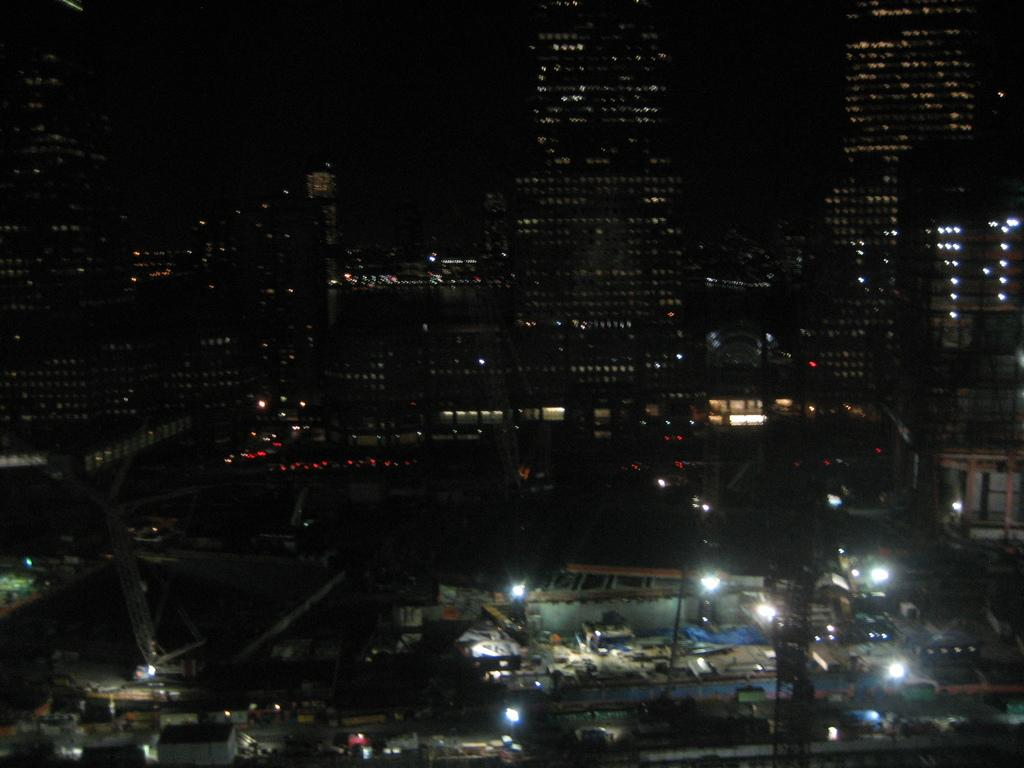What type of structures can be seen in the image? There are buildings in the image. Are there any sources of illumination visible in the image? Yes, there are lights in the image. What else can be observed in the image besides buildings and lights? There are some objects in the image. How would you describe the overall appearance of the image? The background of the image is dark. Can you see a giraffe wearing a collar near the lamp in the image? No, there is no giraffe or lamp present in the image. 